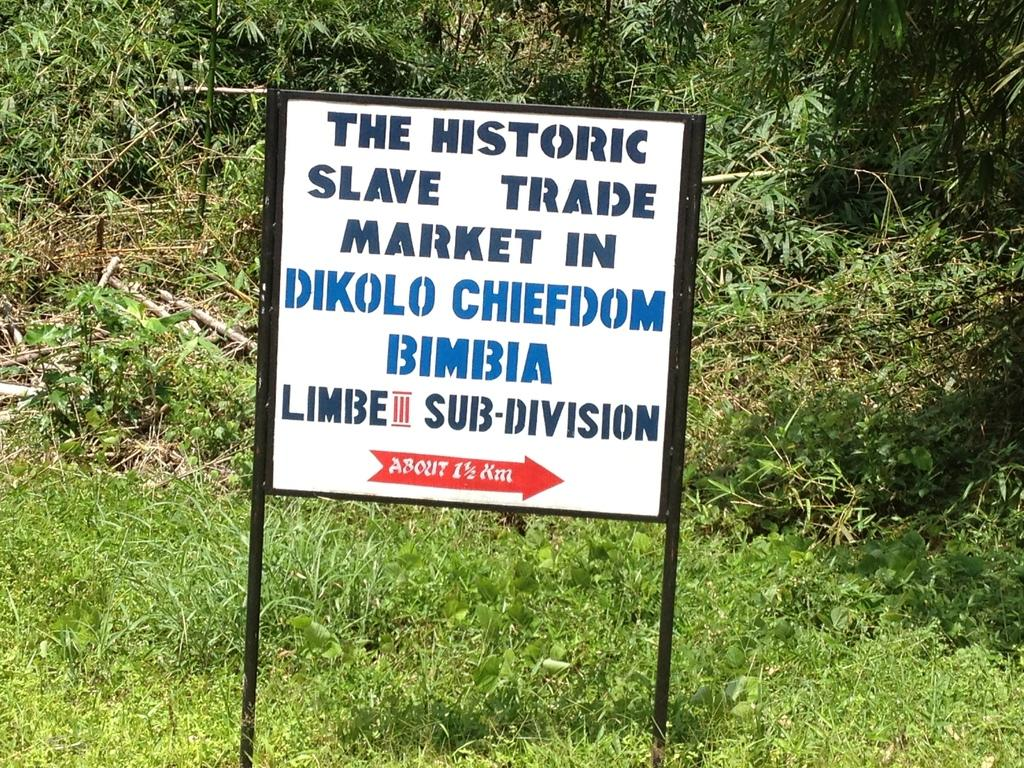What type of vegetation can be seen in the image? There are trees and plants in the image. What covers the ground in the image? There is grass on the ground in the image. What structure is present in the image? There is a sign board in the image. What is written on the sign board? The sign board has text on it. Can you see a bucket being used to water the plants in the image? There is no bucket visible in the image. Are there any yaks grazing on the grass in the image? There are no yaks present in the image. 